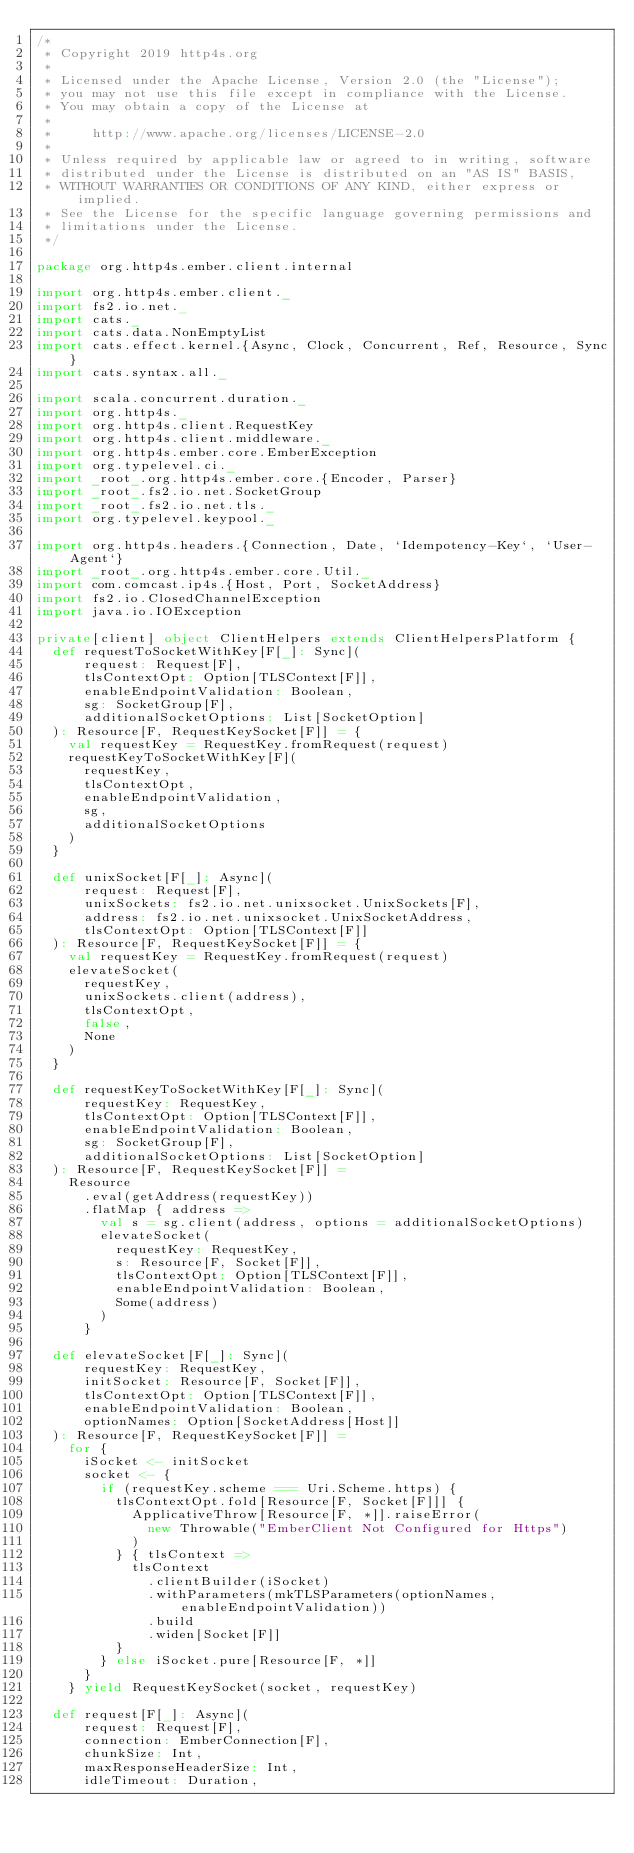<code> <loc_0><loc_0><loc_500><loc_500><_Scala_>/*
 * Copyright 2019 http4s.org
 *
 * Licensed under the Apache License, Version 2.0 (the "License");
 * you may not use this file except in compliance with the License.
 * You may obtain a copy of the License at
 *
 *     http://www.apache.org/licenses/LICENSE-2.0
 *
 * Unless required by applicable law or agreed to in writing, software
 * distributed under the License is distributed on an "AS IS" BASIS,
 * WITHOUT WARRANTIES OR CONDITIONS OF ANY KIND, either express or implied.
 * See the License for the specific language governing permissions and
 * limitations under the License.
 */

package org.http4s.ember.client.internal

import org.http4s.ember.client._
import fs2.io.net._
import cats._
import cats.data.NonEmptyList
import cats.effect.kernel.{Async, Clock, Concurrent, Ref, Resource, Sync}
import cats.syntax.all._

import scala.concurrent.duration._
import org.http4s._
import org.http4s.client.RequestKey
import org.http4s.client.middleware._
import org.http4s.ember.core.EmberException
import org.typelevel.ci._
import _root_.org.http4s.ember.core.{Encoder, Parser}
import _root_.fs2.io.net.SocketGroup
import _root_.fs2.io.net.tls._
import org.typelevel.keypool._

import org.http4s.headers.{Connection, Date, `Idempotency-Key`, `User-Agent`}
import _root_.org.http4s.ember.core.Util._
import com.comcast.ip4s.{Host, Port, SocketAddress}
import fs2.io.ClosedChannelException
import java.io.IOException

private[client] object ClientHelpers extends ClientHelpersPlatform {
  def requestToSocketWithKey[F[_]: Sync](
      request: Request[F],
      tlsContextOpt: Option[TLSContext[F]],
      enableEndpointValidation: Boolean,
      sg: SocketGroup[F],
      additionalSocketOptions: List[SocketOption]
  ): Resource[F, RequestKeySocket[F]] = {
    val requestKey = RequestKey.fromRequest(request)
    requestKeyToSocketWithKey[F](
      requestKey,
      tlsContextOpt,
      enableEndpointValidation,
      sg,
      additionalSocketOptions
    )
  }

  def unixSocket[F[_]: Async](
      request: Request[F],
      unixSockets: fs2.io.net.unixsocket.UnixSockets[F],
      address: fs2.io.net.unixsocket.UnixSocketAddress,
      tlsContextOpt: Option[TLSContext[F]]
  ): Resource[F, RequestKeySocket[F]] = {
    val requestKey = RequestKey.fromRequest(request)
    elevateSocket(
      requestKey,
      unixSockets.client(address),
      tlsContextOpt,
      false,
      None
    )
  }

  def requestKeyToSocketWithKey[F[_]: Sync](
      requestKey: RequestKey,
      tlsContextOpt: Option[TLSContext[F]],
      enableEndpointValidation: Boolean,
      sg: SocketGroup[F],
      additionalSocketOptions: List[SocketOption]
  ): Resource[F, RequestKeySocket[F]] =
    Resource
      .eval(getAddress(requestKey))
      .flatMap { address =>
        val s = sg.client(address, options = additionalSocketOptions)
        elevateSocket(
          requestKey: RequestKey,
          s: Resource[F, Socket[F]],
          tlsContextOpt: Option[TLSContext[F]],
          enableEndpointValidation: Boolean,
          Some(address)
        )
      }

  def elevateSocket[F[_]: Sync](
      requestKey: RequestKey,
      initSocket: Resource[F, Socket[F]],
      tlsContextOpt: Option[TLSContext[F]],
      enableEndpointValidation: Boolean,
      optionNames: Option[SocketAddress[Host]]
  ): Resource[F, RequestKeySocket[F]] =
    for {
      iSocket <- initSocket
      socket <- {
        if (requestKey.scheme === Uri.Scheme.https) {
          tlsContextOpt.fold[Resource[F, Socket[F]]] {
            ApplicativeThrow[Resource[F, *]].raiseError(
              new Throwable("EmberClient Not Configured for Https")
            )
          } { tlsContext =>
            tlsContext
              .clientBuilder(iSocket)
              .withParameters(mkTLSParameters(optionNames, enableEndpointValidation))
              .build
              .widen[Socket[F]]
          }
        } else iSocket.pure[Resource[F, *]]
      }
    } yield RequestKeySocket(socket, requestKey)

  def request[F[_]: Async](
      request: Request[F],
      connection: EmberConnection[F],
      chunkSize: Int,
      maxResponseHeaderSize: Int,
      idleTimeout: Duration,</code> 